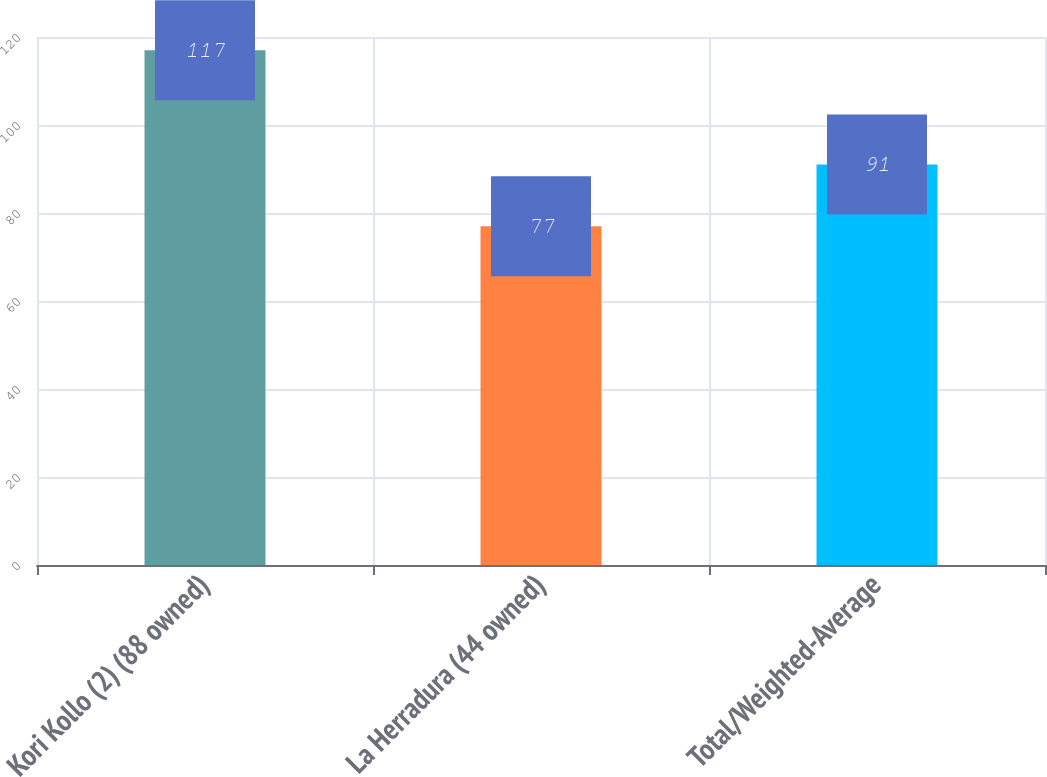<chart> <loc_0><loc_0><loc_500><loc_500><bar_chart><fcel>Kori Kollo (2) (88 owned)<fcel>La Herradura (44 owned)<fcel>Total/Weighted-Average<nl><fcel>117<fcel>77<fcel>91<nl></chart> 